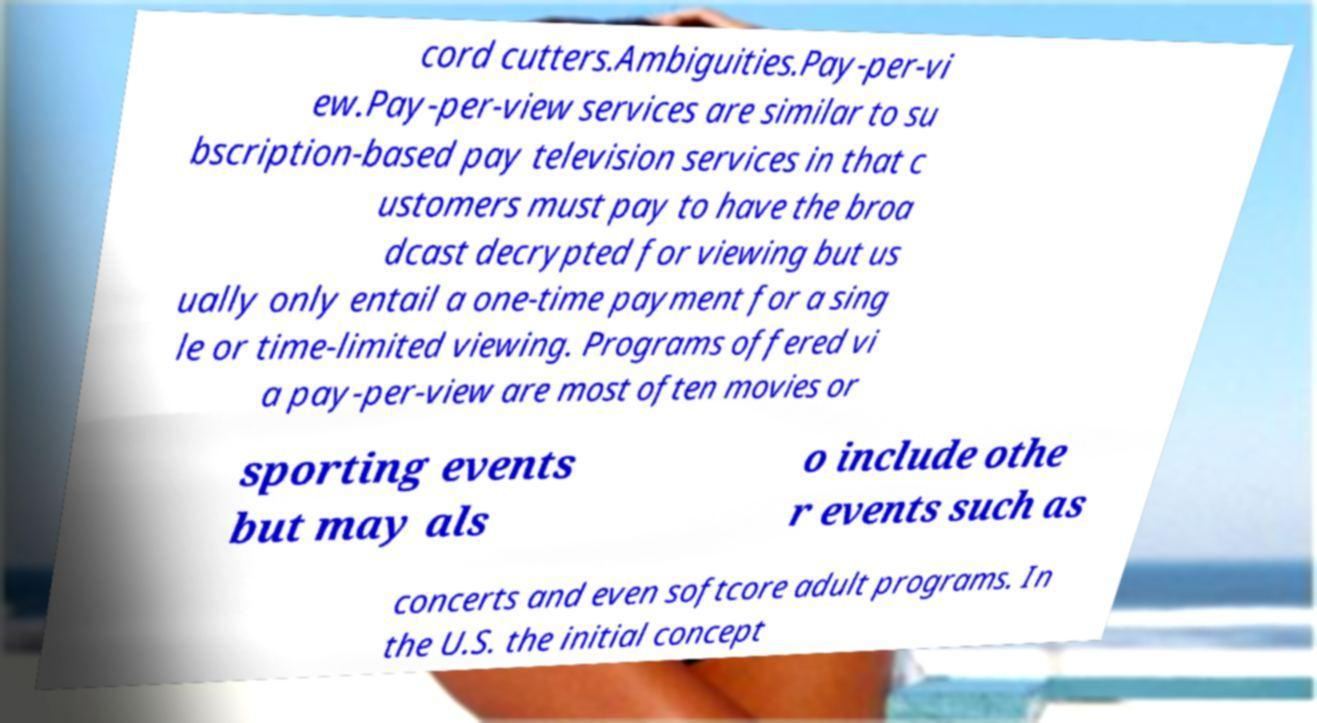Please read and relay the text visible in this image. What does it say? cord cutters.Ambiguities.Pay-per-vi ew.Pay-per-view services are similar to su bscription-based pay television services in that c ustomers must pay to have the broa dcast decrypted for viewing but us ually only entail a one-time payment for a sing le or time-limited viewing. Programs offered vi a pay-per-view are most often movies or sporting events but may als o include othe r events such as concerts and even softcore adult programs. In the U.S. the initial concept 